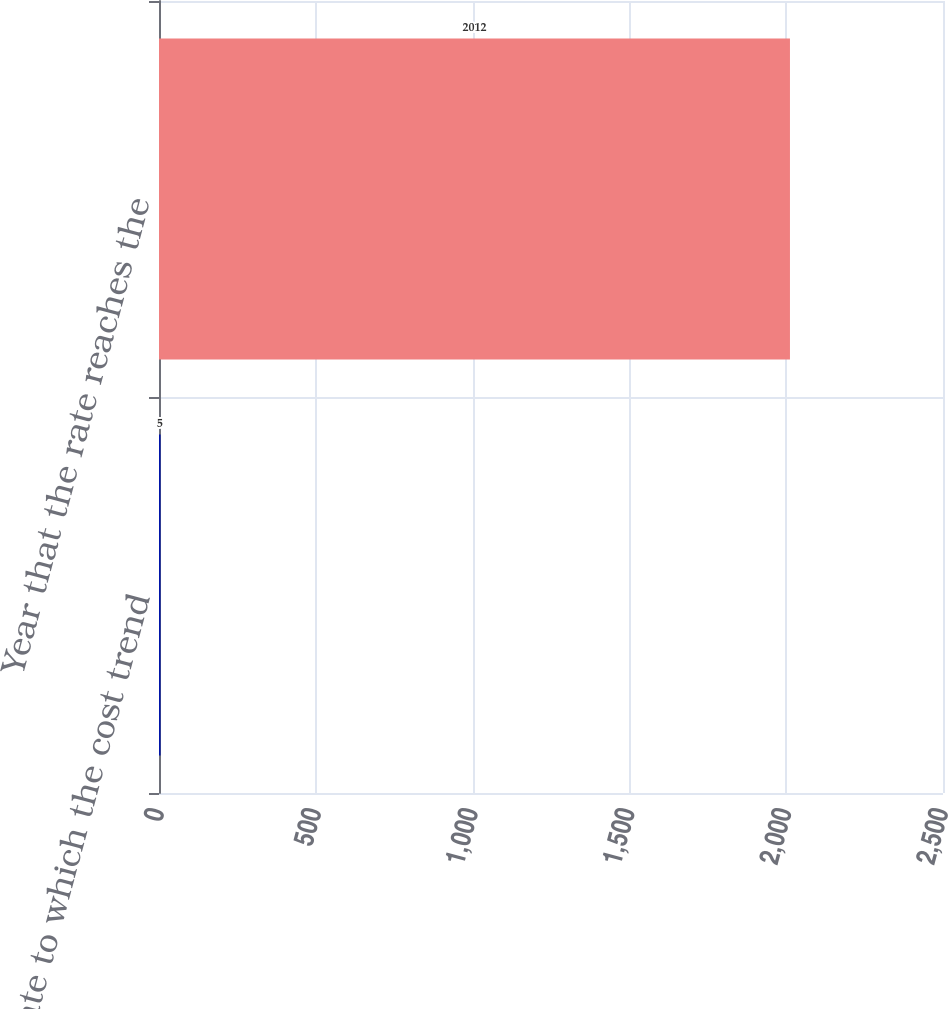Convert chart to OTSL. <chart><loc_0><loc_0><loc_500><loc_500><bar_chart><fcel>Rate to which the cost trend<fcel>Year that the rate reaches the<nl><fcel>5<fcel>2012<nl></chart> 